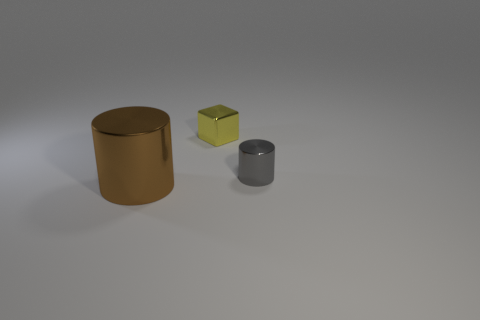Add 2 big green things. How many objects exist? 5 Subtract all gray cylinders. How many cylinders are left? 1 Subtract all cylinders. How many objects are left? 1 Subtract all blue cylinders. Subtract all yellow cubes. How many cylinders are left? 2 Subtract all blue cylinders. How many blue cubes are left? 0 Subtract all big metal cylinders. Subtract all large gray matte cylinders. How many objects are left? 2 Add 3 yellow shiny objects. How many yellow shiny objects are left? 4 Add 1 big shiny objects. How many big shiny objects exist? 2 Subtract 1 gray cylinders. How many objects are left? 2 Subtract 2 cylinders. How many cylinders are left? 0 